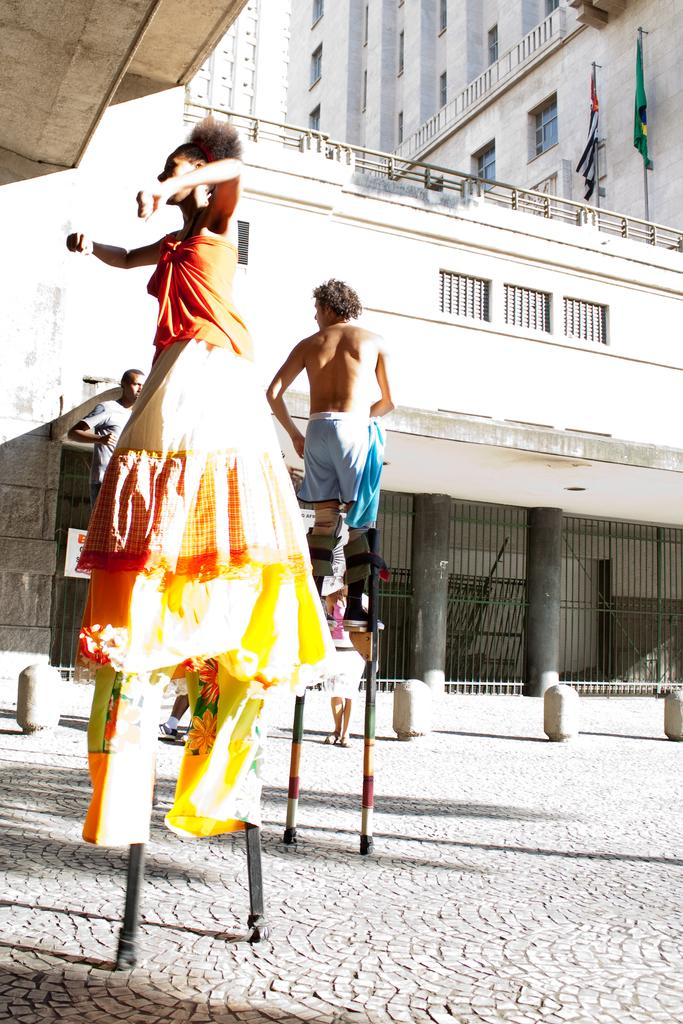What are the people in the image doing? The people in the image are standing on sticks. What action are the people on sticks performing? The people on sticks are walking on a road. What structure is located near the road in the image? There is a building beside the road in the image. What type of pleasure can be seen being consumed by the people in the image? There is no indication of any pleasure being consumed in the image. The people are standing on sticks and walking on a road. --- 